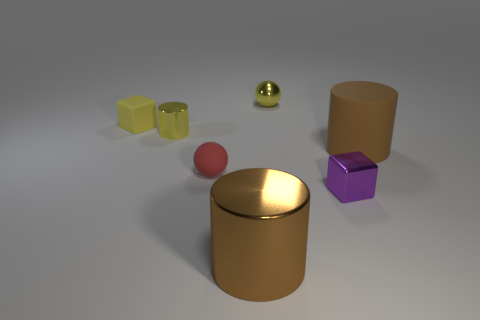Subtract all large brown cylinders. How many cylinders are left? 1 Add 1 tiny blue things. How many objects exist? 8 Subtract all cubes. How many objects are left? 5 Subtract all yellow cylinders. How many cylinders are left? 2 Subtract 2 spheres. How many spheres are left? 0 Subtract all gray balls. How many green cylinders are left? 0 Add 6 brown cylinders. How many brown cylinders exist? 8 Subtract 0 brown balls. How many objects are left? 7 Subtract all green cylinders. Subtract all green blocks. How many cylinders are left? 3 Subtract all tiny shiny cylinders. Subtract all yellow matte things. How many objects are left? 5 